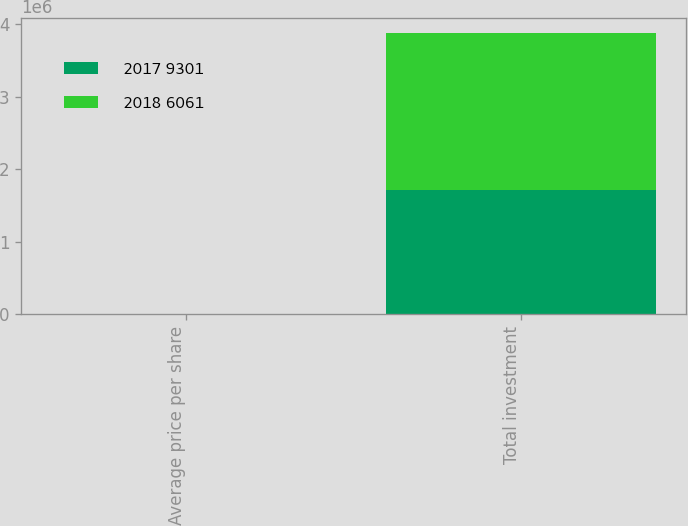Convert chart to OTSL. <chart><loc_0><loc_0><loc_500><loc_500><stacked_bar_chart><ecel><fcel>Average price per share<fcel>Total investment<nl><fcel>2017 9301<fcel>282.8<fcel>1.71395e+06<nl><fcel>2018 6061<fcel>233.57<fcel>2.17244e+06<nl></chart> 